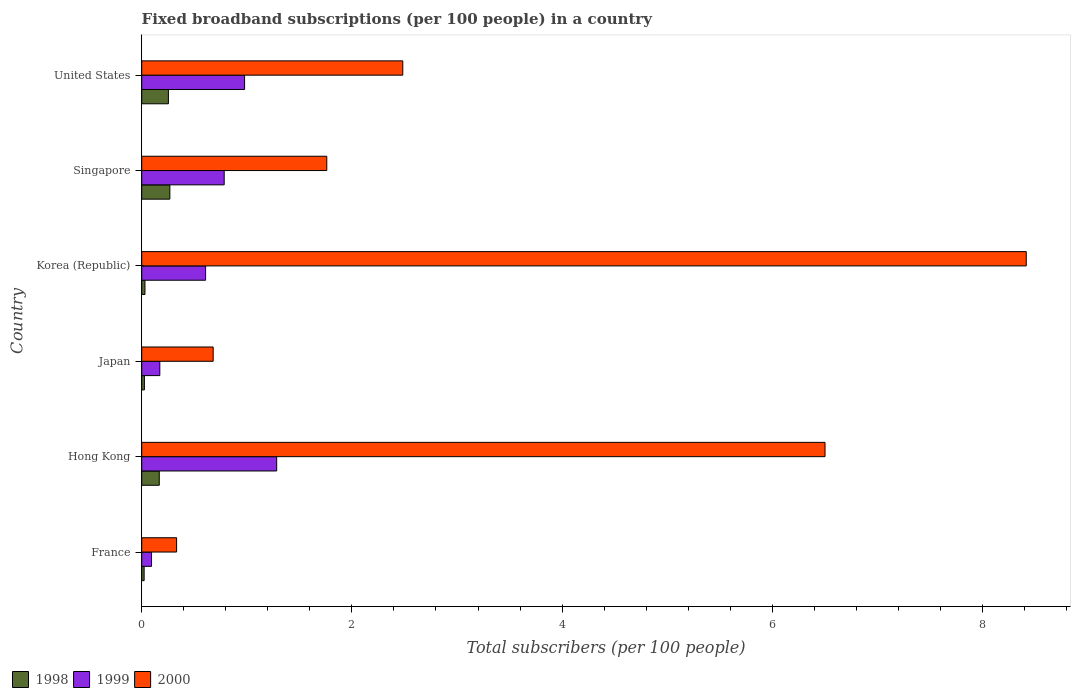How many different coloured bars are there?
Offer a terse response. 3. How many groups of bars are there?
Your answer should be compact. 6. Are the number of bars on each tick of the Y-axis equal?
Keep it short and to the point. Yes. How many bars are there on the 3rd tick from the bottom?
Your answer should be compact. 3. What is the label of the 4th group of bars from the top?
Keep it short and to the point. Japan. In how many cases, is the number of bars for a given country not equal to the number of legend labels?
Provide a short and direct response. 0. What is the number of broadband subscriptions in 1998 in Hong Kong?
Provide a short and direct response. 0.17. Across all countries, what is the maximum number of broadband subscriptions in 1998?
Provide a succinct answer. 0.27. Across all countries, what is the minimum number of broadband subscriptions in 2000?
Your answer should be very brief. 0.33. What is the total number of broadband subscriptions in 1999 in the graph?
Ensure brevity in your answer.  3.92. What is the difference between the number of broadband subscriptions in 1999 in Korea (Republic) and that in United States?
Provide a succinct answer. -0.37. What is the difference between the number of broadband subscriptions in 1999 in Hong Kong and the number of broadband subscriptions in 2000 in Korea (Republic)?
Give a very brief answer. -7.13. What is the average number of broadband subscriptions in 2000 per country?
Your answer should be compact. 3.36. What is the difference between the number of broadband subscriptions in 2000 and number of broadband subscriptions in 1999 in Korea (Republic)?
Offer a terse response. 7.81. In how many countries, is the number of broadband subscriptions in 2000 greater than 5.6 ?
Make the answer very short. 2. What is the ratio of the number of broadband subscriptions in 1998 in France to that in Hong Kong?
Offer a terse response. 0.14. What is the difference between the highest and the second highest number of broadband subscriptions in 1998?
Your response must be concise. 0.01. What is the difference between the highest and the lowest number of broadband subscriptions in 1999?
Offer a terse response. 1.19. What does the 3rd bar from the top in Hong Kong represents?
Keep it short and to the point. 1998. What does the 2nd bar from the bottom in Japan represents?
Provide a short and direct response. 1999. How many bars are there?
Offer a terse response. 18. How many countries are there in the graph?
Offer a terse response. 6. What is the title of the graph?
Give a very brief answer. Fixed broadband subscriptions (per 100 people) in a country. Does "1961" appear as one of the legend labels in the graph?
Offer a terse response. No. What is the label or title of the X-axis?
Your answer should be compact. Total subscribers (per 100 people). What is the label or title of the Y-axis?
Offer a terse response. Country. What is the Total subscribers (per 100 people) of 1998 in France?
Keep it short and to the point. 0.02. What is the Total subscribers (per 100 people) of 1999 in France?
Offer a very short reply. 0.09. What is the Total subscribers (per 100 people) in 2000 in France?
Your response must be concise. 0.33. What is the Total subscribers (per 100 people) of 1998 in Hong Kong?
Keep it short and to the point. 0.17. What is the Total subscribers (per 100 people) of 1999 in Hong Kong?
Your answer should be very brief. 1.28. What is the Total subscribers (per 100 people) in 2000 in Hong Kong?
Give a very brief answer. 6.5. What is the Total subscribers (per 100 people) in 1998 in Japan?
Keep it short and to the point. 0.03. What is the Total subscribers (per 100 people) of 1999 in Japan?
Your answer should be compact. 0.17. What is the Total subscribers (per 100 people) in 2000 in Japan?
Make the answer very short. 0.68. What is the Total subscribers (per 100 people) in 1998 in Korea (Republic)?
Your answer should be very brief. 0.03. What is the Total subscribers (per 100 people) of 1999 in Korea (Republic)?
Make the answer very short. 0.61. What is the Total subscribers (per 100 people) of 2000 in Korea (Republic)?
Your answer should be very brief. 8.42. What is the Total subscribers (per 100 people) in 1998 in Singapore?
Keep it short and to the point. 0.27. What is the Total subscribers (per 100 people) of 1999 in Singapore?
Make the answer very short. 0.78. What is the Total subscribers (per 100 people) in 2000 in Singapore?
Provide a succinct answer. 1.76. What is the Total subscribers (per 100 people) in 1998 in United States?
Provide a short and direct response. 0.25. What is the Total subscribers (per 100 people) of 1999 in United States?
Your response must be concise. 0.98. What is the Total subscribers (per 100 people) of 2000 in United States?
Provide a succinct answer. 2.48. Across all countries, what is the maximum Total subscribers (per 100 people) of 1998?
Your response must be concise. 0.27. Across all countries, what is the maximum Total subscribers (per 100 people) in 1999?
Make the answer very short. 1.28. Across all countries, what is the maximum Total subscribers (per 100 people) in 2000?
Provide a succinct answer. 8.42. Across all countries, what is the minimum Total subscribers (per 100 people) in 1998?
Offer a very short reply. 0.02. Across all countries, what is the minimum Total subscribers (per 100 people) in 1999?
Your response must be concise. 0.09. Across all countries, what is the minimum Total subscribers (per 100 people) of 2000?
Your answer should be compact. 0.33. What is the total Total subscribers (per 100 people) of 1998 in the graph?
Your answer should be compact. 0.77. What is the total Total subscribers (per 100 people) of 1999 in the graph?
Your response must be concise. 3.92. What is the total Total subscribers (per 100 people) of 2000 in the graph?
Keep it short and to the point. 20.18. What is the difference between the Total subscribers (per 100 people) in 1998 in France and that in Hong Kong?
Provide a short and direct response. -0.14. What is the difference between the Total subscribers (per 100 people) in 1999 in France and that in Hong Kong?
Ensure brevity in your answer.  -1.19. What is the difference between the Total subscribers (per 100 people) of 2000 in France and that in Hong Kong?
Provide a succinct answer. -6.17. What is the difference between the Total subscribers (per 100 people) of 1998 in France and that in Japan?
Make the answer very short. -0. What is the difference between the Total subscribers (per 100 people) of 1999 in France and that in Japan?
Your answer should be compact. -0.08. What is the difference between the Total subscribers (per 100 people) in 2000 in France and that in Japan?
Keep it short and to the point. -0.35. What is the difference between the Total subscribers (per 100 people) in 1998 in France and that in Korea (Republic)?
Your answer should be very brief. -0.01. What is the difference between the Total subscribers (per 100 people) in 1999 in France and that in Korea (Republic)?
Offer a terse response. -0.51. What is the difference between the Total subscribers (per 100 people) in 2000 in France and that in Korea (Republic)?
Give a very brief answer. -8.09. What is the difference between the Total subscribers (per 100 people) of 1998 in France and that in Singapore?
Ensure brevity in your answer.  -0.24. What is the difference between the Total subscribers (per 100 people) in 1999 in France and that in Singapore?
Your answer should be compact. -0.69. What is the difference between the Total subscribers (per 100 people) in 2000 in France and that in Singapore?
Make the answer very short. -1.43. What is the difference between the Total subscribers (per 100 people) in 1998 in France and that in United States?
Provide a short and direct response. -0.23. What is the difference between the Total subscribers (per 100 people) of 1999 in France and that in United States?
Offer a very short reply. -0.89. What is the difference between the Total subscribers (per 100 people) of 2000 in France and that in United States?
Your response must be concise. -2.15. What is the difference between the Total subscribers (per 100 people) of 1998 in Hong Kong and that in Japan?
Make the answer very short. 0.14. What is the difference between the Total subscribers (per 100 people) in 1999 in Hong Kong and that in Japan?
Keep it short and to the point. 1.11. What is the difference between the Total subscribers (per 100 people) of 2000 in Hong Kong and that in Japan?
Your answer should be very brief. 5.82. What is the difference between the Total subscribers (per 100 people) in 1998 in Hong Kong and that in Korea (Republic)?
Your answer should be compact. 0.14. What is the difference between the Total subscribers (per 100 people) of 1999 in Hong Kong and that in Korea (Republic)?
Your answer should be very brief. 0.68. What is the difference between the Total subscribers (per 100 people) of 2000 in Hong Kong and that in Korea (Republic)?
Offer a terse response. -1.91. What is the difference between the Total subscribers (per 100 people) of 1998 in Hong Kong and that in Singapore?
Provide a succinct answer. -0.1. What is the difference between the Total subscribers (per 100 people) of 1999 in Hong Kong and that in Singapore?
Provide a succinct answer. 0.5. What is the difference between the Total subscribers (per 100 people) of 2000 in Hong Kong and that in Singapore?
Offer a terse response. 4.74. What is the difference between the Total subscribers (per 100 people) in 1998 in Hong Kong and that in United States?
Your answer should be very brief. -0.09. What is the difference between the Total subscribers (per 100 people) in 1999 in Hong Kong and that in United States?
Offer a very short reply. 0.31. What is the difference between the Total subscribers (per 100 people) of 2000 in Hong Kong and that in United States?
Offer a terse response. 4.02. What is the difference between the Total subscribers (per 100 people) in 1998 in Japan and that in Korea (Republic)?
Provide a short and direct response. -0.01. What is the difference between the Total subscribers (per 100 people) in 1999 in Japan and that in Korea (Republic)?
Make the answer very short. -0.44. What is the difference between the Total subscribers (per 100 people) in 2000 in Japan and that in Korea (Republic)?
Your answer should be very brief. -7.74. What is the difference between the Total subscribers (per 100 people) of 1998 in Japan and that in Singapore?
Provide a succinct answer. -0.24. What is the difference between the Total subscribers (per 100 people) of 1999 in Japan and that in Singapore?
Offer a very short reply. -0.61. What is the difference between the Total subscribers (per 100 people) in 2000 in Japan and that in Singapore?
Give a very brief answer. -1.08. What is the difference between the Total subscribers (per 100 people) in 1998 in Japan and that in United States?
Provide a short and direct response. -0.23. What is the difference between the Total subscribers (per 100 people) of 1999 in Japan and that in United States?
Give a very brief answer. -0.81. What is the difference between the Total subscribers (per 100 people) in 2000 in Japan and that in United States?
Your answer should be compact. -1.8. What is the difference between the Total subscribers (per 100 people) of 1998 in Korea (Republic) and that in Singapore?
Make the answer very short. -0.24. What is the difference between the Total subscribers (per 100 people) in 1999 in Korea (Republic) and that in Singapore?
Offer a terse response. -0.18. What is the difference between the Total subscribers (per 100 people) of 2000 in Korea (Republic) and that in Singapore?
Your response must be concise. 6.66. What is the difference between the Total subscribers (per 100 people) in 1998 in Korea (Republic) and that in United States?
Your answer should be very brief. -0.22. What is the difference between the Total subscribers (per 100 people) in 1999 in Korea (Republic) and that in United States?
Your answer should be compact. -0.37. What is the difference between the Total subscribers (per 100 people) of 2000 in Korea (Republic) and that in United States?
Offer a very short reply. 5.93. What is the difference between the Total subscribers (per 100 people) in 1998 in Singapore and that in United States?
Offer a very short reply. 0.01. What is the difference between the Total subscribers (per 100 people) in 1999 in Singapore and that in United States?
Give a very brief answer. -0.19. What is the difference between the Total subscribers (per 100 people) in 2000 in Singapore and that in United States?
Offer a very short reply. -0.72. What is the difference between the Total subscribers (per 100 people) of 1998 in France and the Total subscribers (per 100 people) of 1999 in Hong Kong?
Your answer should be very brief. -1.26. What is the difference between the Total subscribers (per 100 people) in 1998 in France and the Total subscribers (per 100 people) in 2000 in Hong Kong?
Your answer should be very brief. -6.48. What is the difference between the Total subscribers (per 100 people) of 1999 in France and the Total subscribers (per 100 people) of 2000 in Hong Kong?
Your answer should be compact. -6.41. What is the difference between the Total subscribers (per 100 people) in 1998 in France and the Total subscribers (per 100 people) in 1999 in Japan?
Make the answer very short. -0.15. What is the difference between the Total subscribers (per 100 people) of 1998 in France and the Total subscribers (per 100 people) of 2000 in Japan?
Keep it short and to the point. -0.66. What is the difference between the Total subscribers (per 100 people) of 1999 in France and the Total subscribers (per 100 people) of 2000 in Japan?
Provide a short and direct response. -0.59. What is the difference between the Total subscribers (per 100 people) in 1998 in France and the Total subscribers (per 100 people) in 1999 in Korea (Republic)?
Keep it short and to the point. -0.58. What is the difference between the Total subscribers (per 100 people) of 1998 in France and the Total subscribers (per 100 people) of 2000 in Korea (Republic)?
Your answer should be very brief. -8.39. What is the difference between the Total subscribers (per 100 people) of 1999 in France and the Total subscribers (per 100 people) of 2000 in Korea (Republic)?
Offer a terse response. -8.32. What is the difference between the Total subscribers (per 100 people) of 1998 in France and the Total subscribers (per 100 people) of 1999 in Singapore?
Your response must be concise. -0.76. What is the difference between the Total subscribers (per 100 people) of 1998 in France and the Total subscribers (per 100 people) of 2000 in Singapore?
Your response must be concise. -1.74. What is the difference between the Total subscribers (per 100 people) in 1999 in France and the Total subscribers (per 100 people) in 2000 in Singapore?
Your response must be concise. -1.67. What is the difference between the Total subscribers (per 100 people) in 1998 in France and the Total subscribers (per 100 people) in 1999 in United States?
Your answer should be very brief. -0.96. What is the difference between the Total subscribers (per 100 people) in 1998 in France and the Total subscribers (per 100 people) in 2000 in United States?
Offer a terse response. -2.46. What is the difference between the Total subscribers (per 100 people) of 1999 in France and the Total subscribers (per 100 people) of 2000 in United States?
Provide a succinct answer. -2.39. What is the difference between the Total subscribers (per 100 people) in 1998 in Hong Kong and the Total subscribers (per 100 people) in 1999 in Japan?
Your response must be concise. -0.01. What is the difference between the Total subscribers (per 100 people) of 1998 in Hong Kong and the Total subscribers (per 100 people) of 2000 in Japan?
Keep it short and to the point. -0.51. What is the difference between the Total subscribers (per 100 people) in 1999 in Hong Kong and the Total subscribers (per 100 people) in 2000 in Japan?
Offer a terse response. 0.6. What is the difference between the Total subscribers (per 100 people) of 1998 in Hong Kong and the Total subscribers (per 100 people) of 1999 in Korea (Republic)?
Make the answer very short. -0.44. What is the difference between the Total subscribers (per 100 people) of 1998 in Hong Kong and the Total subscribers (per 100 people) of 2000 in Korea (Republic)?
Provide a short and direct response. -8.25. What is the difference between the Total subscribers (per 100 people) of 1999 in Hong Kong and the Total subscribers (per 100 people) of 2000 in Korea (Republic)?
Provide a succinct answer. -7.13. What is the difference between the Total subscribers (per 100 people) of 1998 in Hong Kong and the Total subscribers (per 100 people) of 1999 in Singapore?
Provide a short and direct response. -0.62. What is the difference between the Total subscribers (per 100 people) in 1998 in Hong Kong and the Total subscribers (per 100 people) in 2000 in Singapore?
Offer a terse response. -1.59. What is the difference between the Total subscribers (per 100 people) in 1999 in Hong Kong and the Total subscribers (per 100 people) in 2000 in Singapore?
Ensure brevity in your answer.  -0.48. What is the difference between the Total subscribers (per 100 people) of 1998 in Hong Kong and the Total subscribers (per 100 people) of 1999 in United States?
Make the answer very short. -0.81. What is the difference between the Total subscribers (per 100 people) of 1998 in Hong Kong and the Total subscribers (per 100 people) of 2000 in United States?
Give a very brief answer. -2.32. What is the difference between the Total subscribers (per 100 people) in 1999 in Hong Kong and the Total subscribers (per 100 people) in 2000 in United States?
Make the answer very short. -1.2. What is the difference between the Total subscribers (per 100 people) in 1998 in Japan and the Total subscribers (per 100 people) in 1999 in Korea (Republic)?
Offer a very short reply. -0.58. What is the difference between the Total subscribers (per 100 people) in 1998 in Japan and the Total subscribers (per 100 people) in 2000 in Korea (Republic)?
Provide a succinct answer. -8.39. What is the difference between the Total subscribers (per 100 people) of 1999 in Japan and the Total subscribers (per 100 people) of 2000 in Korea (Republic)?
Provide a succinct answer. -8.25. What is the difference between the Total subscribers (per 100 people) in 1998 in Japan and the Total subscribers (per 100 people) in 1999 in Singapore?
Your answer should be very brief. -0.76. What is the difference between the Total subscribers (per 100 people) of 1998 in Japan and the Total subscribers (per 100 people) of 2000 in Singapore?
Ensure brevity in your answer.  -1.74. What is the difference between the Total subscribers (per 100 people) of 1999 in Japan and the Total subscribers (per 100 people) of 2000 in Singapore?
Ensure brevity in your answer.  -1.59. What is the difference between the Total subscribers (per 100 people) in 1998 in Japan and the Total subscribers (per 100 people) in 1999 in United States?
Your answer should be very brief. -0.95. What is the difference between the Total subscribers (per 100 people) of 1998 in Japan and the Total subscribers (per 100 people) of 2000 in United States?
Ensure brevity in your answer.  -2.46. What is the difference between the Total subscribers (per 100 people) of 1999 in Japan and the Total subscribers (per 100 people) of 2000 in United States?
Offer a very short reply. -2.31. What is the difference between the Total subscribers (per 100 people) in 1998 in Korea (Republic) and the Total subscribers (per 100 people) in 1999 in Singapore?
Ensure brevity in your answer.  -0.75. What is the difference between the Total subscribers (per 100 people) of 1998 in Korea (Republic) and the Total subscribers (per 100 people) of 2000 in Singapore?
Keep it short and to the point. -1.73. What is the difference between the Total subscribers (per 100 people) of 1999 in Korea (Republic) and the Total subscribers (per 100 people) of 2000 in Singapore?
Make the answer very short. -1.15. What is the difference between the Total subscribers (per 100 people) in 1998 in Korea (Republic) and the Total subscribers (per 100 people) in 1999 in United States?
Give a very brief answer. -0.95. What is the difference between the Total subscribers (per 100 people) of 1998 in Korea (Republic) and the Total subscribers (per 100 people) of 2000 in United States?
Ensure brevity in your answer.  -2.45. What is the difference between the Total subscribers (per 100 people) in 1999 in Korea (Republic) and the Total subscribers (per 100 people) in 2000 in United States?
Give a very brief answer. -1.88. What is the difference between the Total subscribers (per 100 people) in 1998 in Singapore and the Total subscribers (per 100 people) in 1999 in United States?
Your answer should be very brief. -0.71. What is the difference between the Total subscribers (per 100 people) of 1998 in Singapore and the Total subscribers (per 100 people) of 2000 in United States?
Ensure brevity in your answer.  -2.22. What is the difference between the Total subscribers (per 100 people) in 1999 in Singapore and the Total subscribers (per 100 people) in 2000 in United States?
Provide a short and direct response. -1.7. What is the average Total subscribers (per 100 people) in 1998 per country?
Your answer should be compact. 0.13. What is the average Total subscribers (per 100 people) of 1999 per country?
Give a very brief answer. 0.65. What is the average Total subscribers (per 100 people) in 2000 per country?
Provide a short and direct response. 3.36. What is the difference between the Total subscribers (per 100 people) in 1998 and Total subscribers (per 100 people) in 1999 in France?
Provide a succinct answer. -0.07. What is the difference between the Total subscribers (per 100 people) of 1998 and Total subscribers (per 100 people) of 2000 in France?
Your answer should be compact. -0.31. What is the difference between the Total subscribers (per 100 people) of 1999 and Total subscribers (per 100 people) of 2000 in France?
Offer a very short reply. -0.24. What is the difference between the Total subscribers (per 100 people) of 1998 and Total subscribers (per 100 people) of 1999 in Hong Kong?
Offer a very short reply. -1.12. What is the difference between the Total subscribers (per 100 people) of 1998 and Total subscribers (per 100 people) of 2000 in Hong Kong?
Make the answer very short. -6.34. What is the difference between the Total subscribers (per 100 people) of 1999 and Total subscribers (per 100 people) of 2000 in Hong Kong?
Your answer should be very brief. -5.22. What is the difference between the Total subscribers (per 100 people) in 1998 and Total subscribers (per 100 people) in 1999 in Japan?
Provide a succinct answer. -0.15. What is the difference between the Total subscribers (per 100 people) of 1998 and Total subscribers (per 100 people) of 2000 in Japan?
Your answer should be compact. -0.65. What is the difference between the Total subscribers (per 100 people) of 1999 and Total subscribers (per 100 people) of 2000 in Japan?
Your answer should be very brief. -0.51. What is the difference between the Total subscribers (per 100 people) in 1998 and Total subscribers (per 100 people) in 1999 in Korea (Republic)?
Offer a very short reply. -0.58. What is the difference between the Total subscribers (per 100 people) of 1998 and Total subscribers (per 100 people) of 2000 in Korea (Republic)?
Your response must be concise. -8.39. What is the difference between the Total subscribers (per 100 people) of 1999 and Total subscribers (per 100 people) of 2000 in Korea (Republic)?
Provide a short and direct response. -7.81. What is the difference between the Total subscribers (per 100 people) of 1998 and Total subscribers (per 100 people) of 1999 in Singapore?
Give a very brief answer. -0.52. What is the difference between the Total subscribers (per 100 people) in 1998 and Total subscribers (per 100 people) in 2000 in Singapore?
Your response must be concise. -1.49. What is the difference between the Total subscribers (per 100 people) in 1999 and Total subscribers (per 100 people) in 2000 in Singapore?
Your answer should be very brief. -0.98. What is the difference between the Total subscribers (per 100 people) of 1998 and Total subscribers (per 100 people) of 1999 in United States?
Make the answer very short. -0.72. What is the difference between the Total subscribers (per 100 people) in 1998 and Total subscribers (per 100 people) in 2000 in United States?
Keep it short and to the point. -2.23. What is the difference between the Total subscribers (per 100 people) in 1999 and Total subscribers (per 100 people) in 2000 in United States?
Ensure brevity in your answer.  -1.51. What is the ratio of the Total subscribers (per 100 people) of 1998 in France to that in Hong Kong?
Provide a succinct answer. 0.14. What is the ratio of the Total subscribers (per 100 people) of 1999 in France to that in Hong Kong?
Give a very brief answer. 0.07. What is the ratio of the Total subscribers (per 100 people) in 2000 in France to that in Hong Kong?
Give a very brief answer. 0.05. What is the ratio of the Total subscribers (per 100 people) in 1998 in France to that in Japan?
Give a very brief answer. 0.9. What is the ratio of the Total subscribers (per 100 people) in 1999 in France to that in Japan?
Your response must be concise. 0.54. What is the ratio of the Total subscribers (per 100 people) of 2000 in France to that in Japan?
Your answer should be compact. 0.49. What is the ratio of the Total subscribers (per 100 people) of 1998 in France to that in Korea (Republic)?
Provide a succinct answer. 0.75. What is the ratio of the Total subscribers (per 100 people) of 1999 in France to that in Korea (Republic)?
Offer a very short reply. 0.15. What is the ratio of the Total subscribers (per 100 people) of 2000 in France to that in Korea (Republic)?
Ensure brevity in your answer.  0.04. What is the ratio of the Total subscribers (per 100 people) of 1998 in France to that in Singapore?
Make the answer very short. 0.09. What is the ratio of the Total subscribers (per 100 people) in 1999 in France to that in Singapore?
Provide a succinct answer. 0.12. What is the ratio of the Total subscribers (per 100 people) of 2000 in France to that in Singapore?
Offer a very short reply. 0.19. What is the ratio of the Total subscribers (per 100 people) in 1998 in France to that in United States?
Your response must be concise. 0.09. What is the ratio of the Total subscribers (per 100 people) of 1999 in France to that in United States?
Give a very brief answer. 0.1. What is the ratio of the Total subscribers (per 100 people) of 2000 in France to that in United States?
Keep it short and to the point. 0.13. What is the ratio of the Total subscribers (per 100 people) in 1998 in Hong Kong to that in Japan?
Make the answer very short. 6.53. What is the ratio of the Total subscribers (per 100 people) of 1999 in Hong Kong to that in Japan?
Offer a very short reply. 7.46. What is the ratio of the Total subscribers (per 100 people) in 2000 in Hong Kong to that in Japan?
Ensure brevity in your answer.  9.56. What is the ratio of the Total subscribers (per 100 people) of 1998 in Hong Kong to that in Korea (Republic)?
Make the answer very short. 5.42. What is the ratio of the Total subscribers (per 100 people) of 1999 in Hong Kong to that in Korea (Republic)?
Keep it short and to the point. 2.11. What is the ratio of the Total subscribers (per 100 people) in 2000 in Hong Kong to that in Korea (Republic)?
Your response must be concise. 0.77. What is the ratio of the Total subscribers (per 100 people) of 1998 in Hong Kong to that in Singapore?
Provide a short and direct response. 0.62. What is the ratio of the Total subscribers (per 100 people) in 1999 in Hong Kong to that in Singapore?
Your answer should be compact. 1.64. What is the ratio of the Total subscribers (per 100 people) in 2000 in Hong Kong to that in Singapore?
Keep it short and to the point. 3.69. What is the ratio of the Total subscribers (per 100 people) in 1998 in Hong Kong to that in United States?
Make the answer very short. 0.66. What is the ratio of the Total subscribers (per 100 people) of 1999 in Hong Kong to that in United States?
Keep it short and to the point. 1.31. What is the ratio of the Total subscribers (per 100 people) in 2000 in Hong Kong to that in United States?
Offer a terse response. 2.62. What is the ratio of the Total subscribers (per 100 people) of 1998 in Japan to that in Korea (Republic)?
Your response must be concise. 0.83. What is the ratio of the Total subscribers (per 100 people) of 1999 in Japan to that in Korea (Republic)?
Make the answer very short. 0.28. What is the ratio of the Total subscribers (per 100 people) of 2000 in Japan to that in Korea (Republic)?
Provide a succinct answer. 0.08. What is the ratio of the Total subscribers (per 100 people) in 1998 in Japan to that in Singapore?
Give a very brief answer. 0.1. What is the ratio of the Total subscribers (per 100 people) of 1999 in Japan to that in Singapore?
Ensure brevity in your answer.  0.22. What is the ratio of the Total subscribers (per 100 people) in 2000 in Japan to that in Singapore?
Offer a terse response. 0.39. What is the ratio of the Total subscribers (per 100 people) of 1998 in Japan to that in United States?
Your answer should be compact. 0.1. What is the ratio of the Total subscribers (per 100 people) in 1999 in Japan to that in United States?
Provide a short and direct response. 0.18. What is the ratio of the Total subscribers (per 100 people) of 2000 in Japan to that in United States?
Your answer should be compact. 0.27. What is the ratio of the Total subscribers (per 100 people) of 1998 in Korea (Republic) to that in Singapore?
Your response must be concise. 0.12. What is the ratio of the Total subscribers (per 100 people) of 1999 in Korea (Republic) to that in Singapore?
Make the answer very short. 0.77. What is the ratio of the Total subscribers (per 100 people) in 2000 in Korea (Republic) to that in Singapore?
Your answer should be compact. 4.78. What is the ratio of the Total subscribers (per 100 people) of 1998 in Korea (Republic) to that in United States?
Give a very brief answer. 0.12. What is the ratio of the Total subscribers (per 100 people) in 1999 in Korea (Republic) to that in United States?
Make the answer very short. 0.62. What is the ratio of the Total subscribers (per 100 people) in 2000 in Korea (Republic) to that in United States?
Give a very brief answer. 3.39. What is the ratio of the Total subscribers (per 100 people) in 1998 in Singapore to that in United States?
Offer a terse response. 1.05. What is the ratio of the Total subscribers (per 100 people) of 1999 in Singapore to that in United States?
Make the answer very short. 0.8. What is the ratio of the Total subscribers (per 100 people) in 2000 in Singapore to that in United States?
Give a very brief answer. 0.71. What is the difference between the highest and the second highest Total subscribers (per 100 people) in 1998?
Offer a very short reply. 0.01. What is the difference between the highest and the second highest Total subscribers (per 100 people) in 1999?
Your response must be concise. 0.31. What is the difference between the highest and the second highest Total subscribers (per 100 people) of 2000?
Your answer should be compact. 1.91. What is the difference between the highest and the lowest Total subscribers (per 100 people) of 1998?
Your answer should be compact. 0.24. What is the difference between the highest and the lowest Total subscribers (per 100 people) of 1999?
Ensure brevity in your answer.  1.19. What is the difference between the highest and the lowest Total subscribers (per 100 people) in 2000?
Your answer should be very brief. 8.09. 